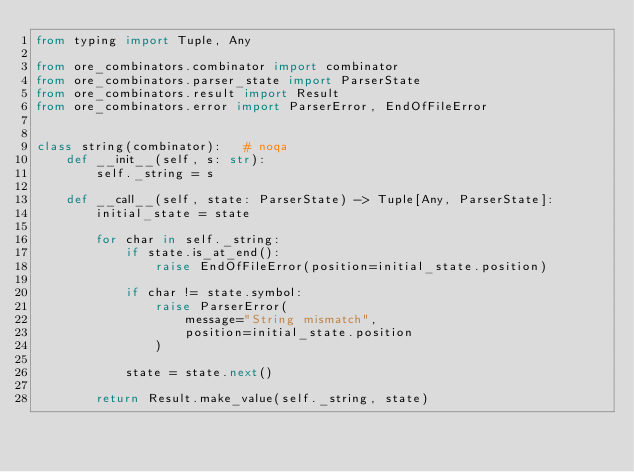Convert code to text. <code><loc_0><loc_0><loc_500><loc_500><_Python_>from typing import Tuple, Any

from ore_combinators.combinator import combinator
from ore_combinators.parser_state import ParserState
from ore_combinators.result import Result
from ore_combinators.error import ParserError, EndOfFileError


class string(combinator):   # noqa
    def __init__(self, s: str):
        self._string = s

    def __call__(self, state: ParserState) -> Tuple[Any, ParserState]:
        initial_state = state

        for char in self._string:
            if state.is_at_end():
                raise EndOfFileError(position=initial_state.position)

            if char != state.symbol:
                raise ParserError(
                    message="String mismatch",
                    position=initial_state.position
                )

            state = state.next()

        return Result.make_value(self._string, state)
</code> 